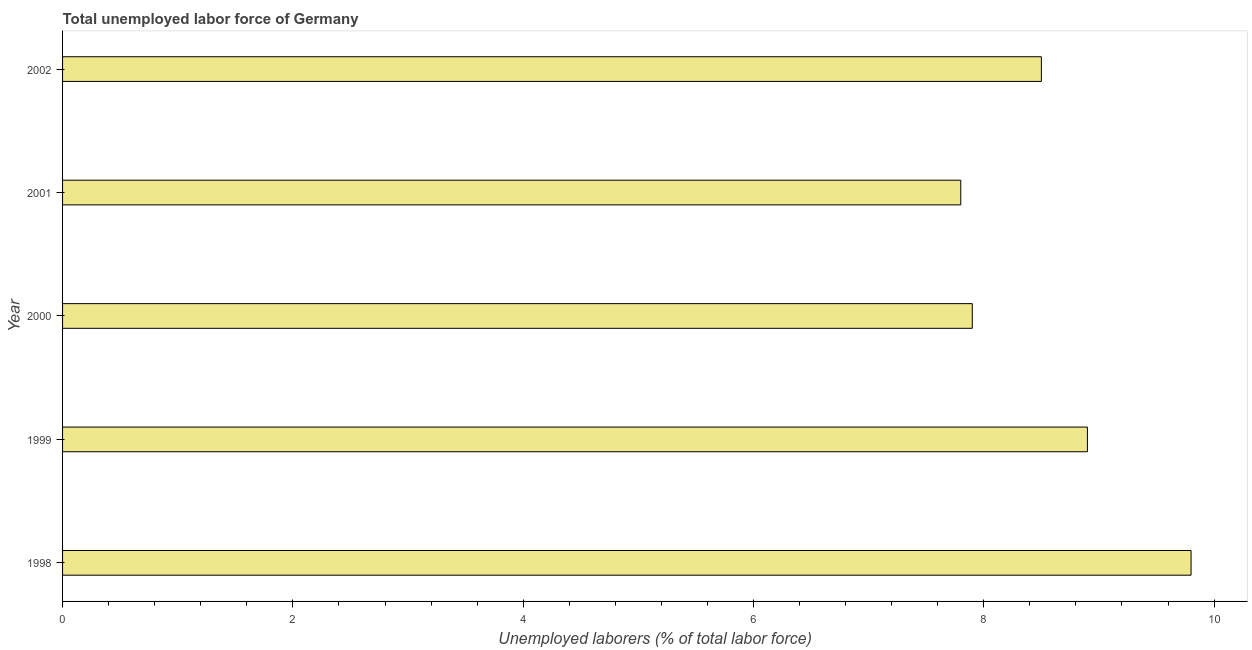What is the title of the graph?
Your answer should be very brief. Total unemployed labor force of Germany. What is the label or title of the X-axis?
Your answer should be compact. Unemployed laborers (% of total labor force). Across all years, what is the maximum total unemployed labour force?
Offer a very short reply. 9.8. Across all years, what is the minimum total unemployed labour force?
Your answer should be compact. 7.8. In which year was the total unemployed labour force minimum?
Keep it short and to the point. 2001. What is the sum of the total unemployed labour force?
Your answer should be very brief. 42.9. What is the difference between the total unemployed labour force in 1999 and 2000?
Keep it short and to the point. 1. What is the average total unemployed labour force per year?
Offer a very short reply. 8.58. What is the median total unemployed labour force?
Keep it short and to the point. 8.5. In how many years, is the total unemployed labour force greater than 7.2 %?
Your answer should be very brief. 5. Is the difference between the total unemployed labour force in 2001 and 2002 greater than the difference between any two years?
Offer a very short reply. No. What is the difference between the highest and the second highest total unemployed labour force?
Keep it short and to the point. 0.9. What is the difference between the highest and the lowest total unemployed labour force?
Provide a short and direct response. 2. In how many years, is the total unemployed labour force greater than the average total unemployed labour force taken over all years?
Offer a terse response. 2. How many years are there in the graph?
Your answer should be compact. 5. What is the Unemployed laborers (% of total labor force) in 1998?
Make the answer very short. 9.8. What is the Unemployed laborers (% of total labor force) in 1999?
Provide a succinct answer. 8.9. What is the Unemployed laborers (% of total labor force) of 2000?
Your response must be concise. 7.9. What is the Unemployed laborers (% of total labor force) of 2001?
Provide a succinct answer. 7.8. What is the difference between the Unemployed laborers (% of total labor force) in 1998 and 1999?
Provide a short and direct response. 0.9. What is the difference between the Unemployed laborers (% of total labor force) in 1998 and 2000?
Make the answer very short. 1.9. What is the difference between the Unemployed laborers (% of total labor force) in 1998 and 2001?
Your answer should be compact. 2. What is the difference between the Unemployed laborers (% of total labor force) in 1998 and 2002?
Your answer should be compact. 1.3. What is the difference between the Unemployed laborers (% of total labor force) in 1999 and 2000?
Make the answer very short. 1. What is the difference between the Unemployed laborers (% of total labor force) in 1999 and 2001?
Offer a terse response. 1.1. What is the ratio of the Unemployed laborers (% of total labor force) in 1998 to that in 1999?
Provide a succinct answer. 1.1. What is the ratio of the Unemployed laborers (% of total labor force) in 1998 to that in 2000?
Give a very brief answer. 1.24. What is the ratio of the Unemployed laborers (% of total labor force) in 1998 to that in 2001?
Provide a short and direct response. 1.26. What is the ratio of the Unemployed laborers (% of total labor force) in 1998 to that in 2002?
Your answer should be very brief. 1.15. What is the ratio of the Unemployed laborers (% of total labor force) in 1999 to that in 2000?
Make the answer very short. 1.13. What is the ratio of the Unemployed laborers (% of total labor force) in 1999 to that in 2001?
Make the answer very short. 1.14. What is the ratio of the Unemployed laborers (% of total labor force) in 1999 to that in 2002?
Give a very brief answer. 1.05. What is the ratio of the Unemployed laborers (% of total labor force) in 2000 to that in 2001?
Provide a succinct answer. 1.01. What is the ratio of the Unemployed laborers (% of total labor force) in 2000 to that in 2002?
Provide a succinct answer. 0.93. What is the ratio of the Unemployed laborers (% of total labor force) in 2001 to that in 2002?
Provide a succinct answer. 0.92. 